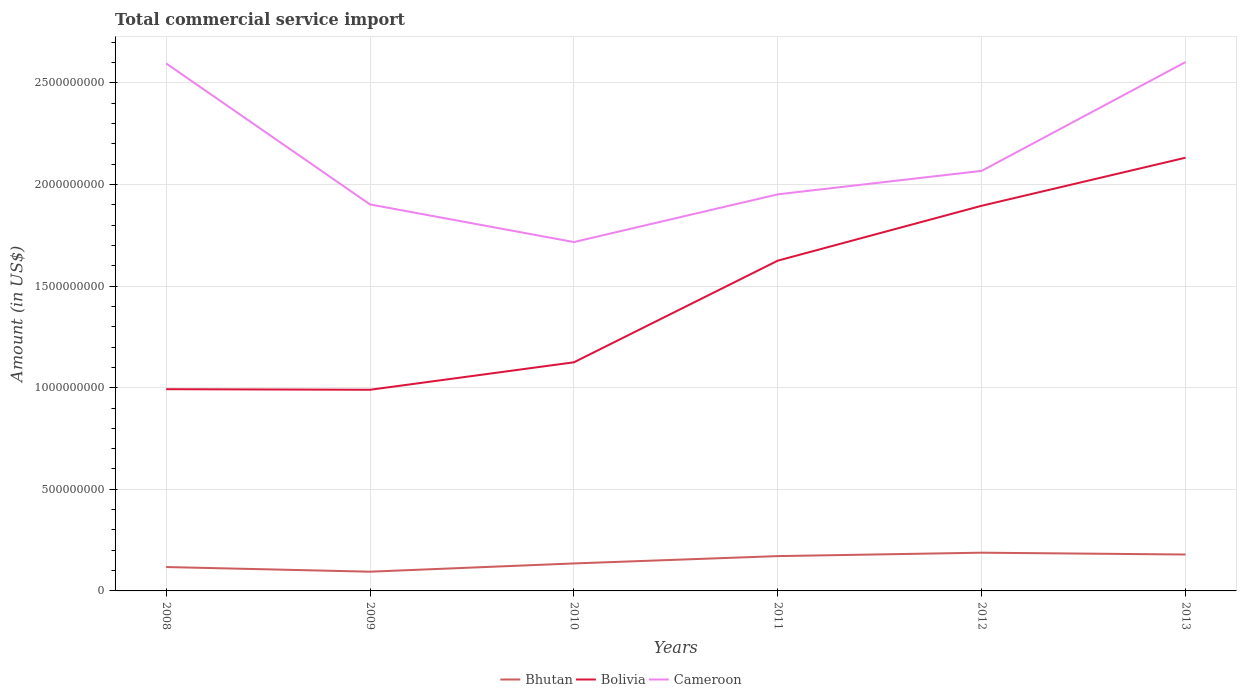How many different coloured lines are there?
Your answer should be very brief. 3. Is the number of lines equal to the number of legend labels?
Ensure brevity in your answer.  Yes. Across all years, what is the maximum total commercial service import in Bolivia?
Make the answer very short. 9.90e+08. What is the total total commercial service import in Bolivia in the graph?
Make the answer very short. 2.86e+06. What is the difference between the highest and the second highest total commercial service import in Cameroon?
Make the answer very short. 8.86e+08. Is the total commercial service import in Bhutan strictly greater than the total commercial service import in Bolivia over the years?
Give a very brief answer. Yes. How many lines are there?
Provide a succinct answer. 3. Are the values on the major ticks of Y-axis written in scientific E-notation?
Provide a short and direct response. No. Does the graph contain grids?
Ensure brevity in your answer.  Yes. How are the legend labels stacked?
Your answer should be compact. Horizontal. What is the title of the graph?
Make the answer very short. Total commercial service import. What is the label or title of the X-axis?
Give a very brief answer. Years. What is the Amount (in US$) of Bhutan in 2008?
Provide a succinct answer. 1.18e+08. What is the Amount (in US$) of Bolivia in 2008?
Keep it short and to the point. 9.93e+08. What is the Amount (in US$) in Cameroon in 2008?
Your response must be concise. 2.60e+09. What is the Amount (in US$) of Bhutan in 2009?
Your response must be concise. 9.46e+07. What is the Amount (in US$) of Bolivia in 2009?
Keep it short and to the point. 9.90e+08. What is the Amount (in US$) of Cameroon in 2009?
Provide a short and direct response. 1.90e+09. What is the Amount (in US$) of Bhutan in 2010?
Make the answer very short. 1.35e+08. What is the Amount (in US$) in Bolivia in 2010?
Give a very brief answer. 1.13e+09. What is the Amount (in US$) of Cameroon in 2010?
Give a very brief answer. 1.72e+09. What is the Amount (in US$) of Bhutan in 2011?
Ensure brevity in your answer.  1.71e+08. What is the Amount (in US$) of Bolivia in 2011?
Offer a terse response. 1.63e+09. What is the Amount (in US$) in Cameroon in 2011?
Your response must be concise. 1.95e+09. What is the Amount (in US$) in Bhutan in 2012?
Your response must be concise. 1.88e+08. What is the Amount (in US$) of Bolivia in 2012?
Keep it short and to the point. 1.90e+09. What is the Amount (in US$) in Cameroon in 2012?
Offer a very short reply. 2.07e+09. What is the Amount (in US$) in Bhutan in 2013?
Offer a terse response. 1.79e+08. What is the Amount (in US$) in Bolivia in 2013?
Provide a short and direct response. 2.13e+09. What is the Amount (in US$) in Cameroon in 2013?
Your answer should be compact. 2.60e+09. Across all years, what is the maximum Amount (in US$) in Bhutan?
Provide a succinct answer. 1.88e+08. Across all years, what is the maximum Amount (in US$) in Bolivia?
Ensure brevity in your answer.  2.13e+09. Across all years, what is the maximum Amount (in US$) in Cameroon?
Offer a terse response. 2.60e+09. Across all years, what is the minimum Amount (in US$) of Bhutan?
Offer a very short reply. 9.46e+07. Across all years, what is the minimum Amount (in US$) of Bolivia?
Offer a terse response. 9.90e+08. Across all years, what is the minimum Amount (in US$) of Cameroon?
Offer a very short reply. 1.72e+09. What is the total Amount (in US$) of Bhutan in the graph?
Offer a very short reply. 8.86e+08. What is the total Amount (in US$) of Bolivia in the graph?
Your response must be concise. 8.76e+09. What is the total Amount (in US$) in Cameroon in the graph?
Your response must be concise. 1.28e+1. What is the difference between the Amount (in US$) in Bhutan in 2008 and that in 2009?
Provide a short and direct response. 2.29e+07. What is the difference between the Amount (in US$) in Bolivia in 2008 and that in 2009?
Provide a short and direct response. 2.86e+06. What is the difference between the Amount (in US$) in Cameroon in 2008 and that in 2009?
Provide a short and direct response. 6.94e+08. What is the difference between the Amount (in US$) in Bhutan in 2008 and that in 2010?
Provide a short and direct response. -1.77e+07. What is the difference between the Amount (in US$) of Bolivia in 2008 and that in 2010?
Give a very brief answer. -1.32e+08. What is the difference between the Amount (in US$) of Cameroon in 2008 and that in 2010?
Ensure brevity in your answer.  8.79e+08. What is the difference between the Amount (in US$) in Bhutan in 2008 and that in 2011?
Keep it short and to the point. -5.38e+07. What is the difference between the Amount (in US$) of Bolivia in 2008 and that in 2011?
Your answer should be compact. -6.33e+08. What is the difference between the Amount (in US$) in Cameroon in 2008 and that in 2011?
Offer a terse response. 6.44e+08. What is the difference between the Amount (in US$) of Bhutan in 2008 and that in 2012?
Offer a terse response. -7.06e+07. What is the difference between the Amount (in US$) in Bolivia in 2008 and that in 2012?
Give a very brief answer. -9.03e+08. What is the difference between the Amount (in US$) in Cameroon in 2008 and that in 2012?
Offer a terse response. 5.29e+08. What is the difference between the Amount (in US$) of Bhutan in 2008 and that in 2013?
Your answer should be compact. -6.16e+07. What is the difference between the Amount (in US$) of Bolivia in 2008 and that in 2013?
Make the answer very short. -1.14e+09. What is the difference between the Amount (in US$) in Cameroon in 2008 and that in 2013?
Make the answer very short. -6.72e+06. What is the difference between the Amount (in US$) in Bhutan in 2009 and that in 2010?
Make the answer very short. -4.06e+07. What is the difference between the Amount (in US$) of Bolivia in 2009 and that in 2010?
Your response must be concise. -1.35e+08. What is the difference between the Amount (in US$) in Cameroon in 2009 and that in 2010?
Your answer should be very brief. 1.85e+08. What is the difference between the Amount (in US$) in Bhutan in 2009 and that in 2011?
Your response must be concise. -7.67e+07. What is the difference between the Amount (in US$) of Bolivia in 2009 and that in 2011?
Offer a very short reply. -6.35e+08. What is the difference between the Amount (in US$) of Cameroon in 2009 and that in 2011?
Keep it short and to the point. -4.97e+07. What is the difference between the Amount (in US$) of Bhutan in 2009 and that in 2012?
Offer a very short reply. -9.35e+07. What is the difference between the Amount (in US$) of Bolivia in 2009 and that in 2012?
Ensure brevity in your answer.  -9.05e+08. What is the difference between the Amount (in US$) in Cameroon in 2009 and that in 2012?
Offer a very short reply. -1.65e+08. What is the difference between the Amount (in US$) of Bhutan in 2009 and that in 2013?
Your answer should be compact. -8.45e+07. What is the difference between the Amount (in US$) in Bolivia in 2009 and that in 2013?
Offer a very short reply. -1.14e+09. What is the difference between the Amount (in US$) of Cameroon in 2009 and that in 2013?
Provide a succinct answer. -7.01e+08. What is the difference between the Amount (in US$) of Bhutan in 2010 and that in 2011?
Provide a succinct answer. -3.61e+07. What is the difference between the Amount (in US$) in Bolivia in 2010 and that in 2011?
Your answer should be compact. -5.00e+08. What is the difference between the Amount (in US$) of Cameroon in 2010 and that in 2011?
Give a very brief answer. -2.35e+08. What is the difference between the Amount (in US$) in Bhutan in 2010 and that in 2012?
Provide a short and direct response. -5.29e+07. What is the difference between the Amount (in US$) in Bolivia in 2010 and that in 2012?
Your answer should be compact. -7.70e+08. What is the difference between the Amount (in US$) in Cameroon in 2010 and that in 2012?
Offer a terse response. -3.50e+08. What is the difference between the Amount (in US$) in Bhutan in 2010 and that in 2013?
Ensure brevity in your answer.  -4.39e+07. What is the difference between the Amount (in US$) of Bolivia in 2010 and that in 2013?
Provide a short and direct response. -1.01e+09. What is the difference between the Amount (in US$) in Cameroon in 2010 and that in 2013?
Make the answer very short. -8.86e+08. What is the difference between the Amount (in US$) in Bhutan in 2011 and that in 2012?
Provide a succinct answer. -1.68e+07. What is the difference between the Amount (in US$) of Bolivia in 2011 and that in 2012?
Your response must be concise. -2.70e+08. What is the difference between the Amount (in US$) in Cameroon in 2011 and that in 2012?
Ensure brevity in your answer.  -1.15e+08. What is the difference between the Amount (in US$) in Bhutan in 2011 and that in 2013?
Your response must be concise. -7.82e+06. What is the difference between the Amount (in US$) in Bolivia in 2011 and that in 2013?
Offer a terse response. -5.07e+08. What is the difference between the Amount (in US$) of Cameroon in 2011 and that in 2013?
Give a very brief answer. -6.51e+08. What is the difference between the Amount (in US$) in Bhutan in 2012 and that in 2013?
Ensure brevity in your answer.  8.97e+06. What is the difference between the Amount (in US$) of Bolivia in 2012 and that in 2013?
Make the answer very short. -2.37e+08. What is the difference between the Amount (in US$) in Cameroon in 2012 and that in 2013?
Provide a short and direct response. -5.35e+08. What is the difference between the Amount (in US$) of Bhutan in 2008 and the Amount (in US$) of Bolivia in 2009?
Provide a short and direct response. -8.72e+08. What is the difference between the Amount (in US$) of Bhutan in 2008 and the Amount (in US$) of Cameroon in 2009?
Your response must be concise. -1.78e+09. What is the difference between the Amount (in US$) of Bolivia in 2008 and the Amount (in US$) of Cameroon in 2009?
Make the answer very short. -9.09e+08. What is the difference between the Amount (in US$) of Bhutan in 2008 and the Amount (in US$) of Bolivia in 2010?
Offer a terse response. -1.01e+09. What is the difference between the Amount (in US$) of Bhutan in 2008 and the Amount (in US$) of Cameroon in 2010?
Keep it short and to the point. -1.60e+09. What is the difference between the Amount (in US$) of Bolivia in 2008 and the Amount (in US$) of Cameroon in 2010?
Make the answer very short. -7.24e+08. What is the difference between the Amount (in US$) in Bhutan in 2008 and the Amount (in US$) in Bolivia in 2011?
Make the answer very short. -1.51e+09. What is the difference between the Amount (in US$) in Bhutan in 2008 and the Amount (in US$) in Cameroon in 2011?
Provide a short and direct response. -1.83e+09. What is the difference between the Amount (in US$) in Bolivia in 2008 and the Amount (in US$) in Cameroon in 2011?
Your response must be concise. -9.59e+08. What is the difference between the Amount (in US$) of Bhutan in 2008 and the Amount (in US$) of Bolivia in 2012?
Ensure brevity in your answer.  -1.78e+09. What is the difference between the Amount (in US$) in Bhutan in 2008 and the Amount (in US$) in Cameroon in 2012?
Your answer should be very brief. -1.95e+09. What is the difference between the Amount (in US$) in Bolivia in 2008 and the Amount (in US$) in Cameroon in 2012?
Your response must be concise. -1.07e+09. What is the difference between the Amount (in US$) in Bhutan in 2008 and the Amount (in US$) in Bolivia in 2013?
Your answer should be compact. -2.01e+09. What is the difference between the Amount (in US$) of Bhutan in 2008 and the Amount (in US$) of Cameroon in 2013?
Keep it short and to the point. -2.48e+09. What is the difference between the Amount (in US$) in Bolivia in 2008 and the Amount (in US$) in Cameroon in 2013?
Make the answer very short. -1.61e+09. What is the difference between the Amount (in US$) in Bhutan in 2009 and the Amount (in US$) in Bolivia in 2010?
Give a very brief answer. -1.03e+09. What is the difference between the Amount (in US$) in Bhutan in 2009 and the Amount (in US$) in Cameroon in 2010?
Offer a very short reply. -1.62e+09. What is the difference between the Amount (in US$) of Bolivia in 2009 and the Amount (in US$) of Cameroon in 2010?
Your answer should be very brief. -7.27e+08. What is the difference between the Amount (in US$) in Bhutan in 2009 and the Amount (in US$) in Bolivia in 2011?
Provide a short and direct response. -1.53e+09. What is the difference between the Amount (in US$) of Bhutan in 2009 and the Amount (in US$) of Cameroon in 2011?
Keep it short and to the point. -1.86e+09. What is the difference between the Amount (in US$) of Bolivia in 2009 and the Amount (in US$) of Cameroon in 2011?
Ensure brevity in your answer.  -9.62e+08. What is the difference between the Amount (in US$) of Bhutan in 2009 and the Amount (in US$) of Bolivia in 2012?
Make the answer very short. -1.80e+09. What is the difference between the Amount (in US$) of Bhutan in 2009 and the Amount (in US$) of Cameroon in 2012?
Make the answer very short. -1.97e+09. What is the difference between the Amount (in US$) of Bolivia in 2009 and the Amount (in US$) of Cameroon in 2012?
Your response must be concise. -1.08e+09. What is the difference between the Amount (in US$) in Bhutan in 2009 and the Amount (in US$) in Bolivia in 2013?
Offer a very short reply. -2.04e+09. What is the difference between the Amount (in US$) of Bhutan in 2009 and the Amount (in US$) of Cameroon in 2013?
Your answer should be compact. -2.51e+09. What is the difference between the Amount (in US$) in Bolivia in 2009 and the Amount (in US$) in Cameroon in 2013?
Your answer should be very brief. -1.61e+09. What is the difference between the Amount (in US$) of Bhutan in 2010 and the Amount (in US$) of Bolivia in 2011?
Your answer should be compact. -1.49e+09. What is the difference between the Amount (in US$) in Bhutan in 2010 and the Amount (in US$) in Cameroon in 2011?
Offer a very short reply. -1.82e+09. What is the difference between the Amount (in US$) in Bolivia in 2010 and the Amount (in US$) in Cameroon in 2011?
Keep it short and to the point. -8.27e+08. What is the difference between the Amount (in US$) in Bhutan in 2010 and the Amount (in US$) in Bolivia in 2012?
Offer a terse response. -1.76e+09. What is the difference between the Amount (in US$) in Bhutan in 2010 and the Amount (in US$) in Cameroon in 2012?
Your response must be concise. -1.93e+09. What is the difference between the Amount (in US$) in Bolivia in 2010 and the Amount (in US$) in Cameroon in 2012?
Give a very brief answer. -9.42e+08. What is the difference between the Amount (in US$) in Bhutan in 2010 and the Amount (in US$) in Bolivia in 2013?
Provide a succinct answer. -2.00e+09. What is the difference between the Amount (in US$) of Bhutan in 2010 and the Amount (in US$) of Cameroon in 2013?
Ensure brevity in your answer.  -2.47e+09. What is the difference between the Amount (in US$) of Bolivia in 2010 and the Amount (in US$) of Cameroon in 2013?
Your response must be concise. -1.48e+09. What is the difference between the Amount (in US$) of Bhutan in 2011 and the Amount (in US$) of Bolivia in 2012?
Offer a terse response. -1.72e+09. What is the difference between the Amount (in US$) of Bhutan in 2011 and the Amount (in US$) of Cameroon in 2012?
Offer a very short reply. -1.90e+09. What is the difference between the Amount (in US$) in Bolivia in 2011 and the Amount (in US$) in Cameroon in 2012?
Provide a succinct answer. -4.42e+08. What is the difference between the Amount (in US$) in Bhutan in 2011 and the Amount (in US$) in Bolivia in 2013?
Give a very brief answer. -1.96e+09. What is the difference between the Amount (in US$) in Bhutan in 2011 and the Amount (in US$) in Cameroon in 2013?
Provide a short and direct response. -2.43e+09. What is the difference between the Amount (in US$) in Bolivia in 2011 and the Amount (in US$) in Cameroon in 2013?
Your answer should be very brief. -9.77e+08. What is the difference between the Amount (in US$) of Bhutan in 2012 and the Amount (in US$) of Bolivia in 2013?
Provide a succinct answer. -1.94e+09. What is the difference between the Amount (in US$) of Bhutan in 2012 and the Amount (in US$) of Cameroon in 2013?
Ensure brevity in your answer.  -2.41e+09. What is the difference between the Amount (in US$) in Bolivia in 2012 and the Amount (in US$) in Cameroon in 2013?
Provide a succinct answer. -7.07e+08. What is the average Amount (in US$) of Bhutan per year?
Keep it short and to the point. 1.48e+08. What is the average Amount (in US$) in Bolivia per year?
Provide a succinct answer. 1.46e+09. What is the average Amount (in US$) in Cameroon per year?
Your answer should be compact. 2.14e+09. In the year 2008, what is the difference between the Amount (in US$) in Bhutan and Amount (in US$) in Bolivia?
Your answer should be compact. -8.75e+08. In the year 2008, what is the difference between the Amount (in US$) in Bhutan and Amount (in US$) in Cameroon?
Provide a succinct answer. -2.48e+09. In the year 2008, what is the difference between the Amount (in US$) in Bolivia and Amount (in US$) in Cameroon?
Provide a succinct answer. -1.60e+09. In the year 2009, what is the difference between the Amount (in US$) in Bhutan and Amount (in US$) in Bolivia?
Offer a very short reply. -8.95e+08. In the year 2009, what is the difference between the Amount (in US$) in Bhutan and Amount (in US$) in Cameroon?
Make the answer very short. -1.81e+09. In the year 2009, what is the difference between the Amount (in US$) of Bolivia and Amount (in US$) of Cameroon?
Provide a short and direct response. -9.12e+08. In the year 2010, what is the difference between the Amount (in US$) of Bhutan and Amount (in US$) of Bolivia?
Provide a succinct answer. -9.90e+08. In the year 2010, what is the difference between the Amount (in US$) in Bhutan and Amount (in US$) in Cameroon?
Give a very brief answer. -1.58e+09. In the year 2010, what is the difference between the Amount (in US$) in Bolivia and Amount (in US$) in Cameroon?
Your answer should be very brief. -5.92e+08. In the year 2011, what is the difference between the Amount (in US$) in Bhutan and Amount (in US$) in Bolivia?
Your answer should be compact. -1.45e+09. In the year 2011, what is the difference between the Amount (in US$) in Bhutan and Amount (in US$) in Cameroon?
Provide a succinct answer. -1.78e+09. In the year 2011, what is the difference between the Amount (in US$) of Bolivia and Amount (in US$) of Cameroon?
Your response must be concise. -3.26e+08. In the year 2012, what is the difference between the Amount (in US$) in Bhutan and Amount (in US$) in Bolivia?
Offer a terse response. -1.71e+09. In the year 2012, what is the difference between the Amount (in US$) of Bhutan and Amount (in US$) of Cameroon?
Give a very brief answer. -1.88e+09. In the year 2012, what is the difference between the Amount (in US$) in Bolivia and Amount (in US$) in Cameroon?
Offer a very short reply. -1.72e+08. In the year 2013, what is the difference between the Amount (in US$) of Bhutan and Amount (in US$) of Bolivia?
Provide a succinct answer. -1.95e+09. In the year 2013, what is the difference between the Amount (in US$) in Bhutan and Amount (in US$) in Cameroon?
Offer a very short reply. -2.42e+09. In the year 2013, what is the difference between the Amount (in US$) in Bolivia and Amount (in US$) in Cameroon?
Give a very brief answer. -4.71e+08. What is the ratio of the Amount (in US$) in Bhutan in 2008 to that in 2009?
Make the answer very short. 1.24. What is the ratio of the Amount (in US$) in Bolivia in 2008 to that in 2009?
Offer a very short reply. 1. What is the ratio of the Amount (in US$) in Cameroon in 2008 to that in 2009?
Ensure brevity in your answer.  1.36. What is the ratio of the Amount (in US$) of Bhutan in 2008 to that in 2010?
Make the answer very short. 0.87. What is the ratio of the Amount (in US$) of Bolivia in 2008 to that in 2010?
Your answer should be very brief. 0.88. What is the ratio of the Amount (in US$) of Cameroon in 2008 to that in 2010?
Give a very brief answer. 1.51. What is the ratio of the Amount (in US$) of Bhutan in 2008 to that in 2011?
Provide a succinct answer. 0.69. What is the ratio of the Amount (in US$) in Bolivia in 2008 to that in 2011?
Your response must be concise. 0.61. What is the ratio of the Amount (in US$) in Cameroon in 2008 to that in 2011?
Your answer should be compact. 1.33. What is the ratio of the Amount (in US$) in Bhutan in 2008 to that in 2012?
Keep it short and to the point. 0.62. What is the ratio of the Amount (in US$) of Bolivia in 2008 to that in 2012?
Give a very brief answer. 0.52. What is the ratio of the Amount (in US$) in Cameroon in 2008 to that in 2012?
Give a very brief answer. 1.26. What is the ratio of the Amount (in US$) in Bhutan in 2008 to that in 2013?
Provide a short and direct response. 0.66. What is the ratio of the Amount (in US$) of Bolivia in 2008 to that in 2013?
Keep it short and to the point. 0.47. What is the ratio of the Amount (in US$) in Cameroon in 2008 to that in 2013?
Give a very brief answer. 1. What is the ratio of the Amount (in US$) in Bhutan in 2009 to that in 2010?
Provide a succinct answer. 0.7. What is the ratio of the Amount (in US$) in Bolivia in 2009 to that in 2010?
Your response must be concise. 0.88. What is the ratio of the Amount (in US$) of Cameroon in 2009 to that in 2010?
Your answer should be very brief. 1.11. What is the ratio of the Amount (in US$) in Bhutan in 2009 to that in 2011?
Ensure brevity in your answer.  0.55. What is the ratio of the Amount (in US$) in Bolivia in 2009 to that in 2011?
Your answer should be very brief. 0.61. What is the ratio of the Amount (in US$) in Cameroon in 2009 to that in 2011?
Your answer should be very brief. 0.97. What is the ratio of the Amount (in US$) in Bhutan in 2009 to that in 2012?
Provide a succinct answer. 0.5. What is the ratio of the Amount (in US$) of Bolivia in 2009 to that in 2012?
Provide a short and direct response. 0.52. What is the ratio of the Amount (in US$) of Cameroon in 2009 to that in 2012?
Make the answer very short. 0.92. What is the ratio of the Amount (in US$) in Bhutan in 2009 to that in 2013?
Your response must be concise. 0.53. What is the ratio of the Amount (in US$) in Bolivia in 2009 to that in 2013?
Offer a terse response. 0.46. What is the ratio of the Amount (in US$) in Cameroon in 2009 to that in 2013?
Ensure brevity in your answer.  0.73. What is the ratio of the Amount (in US$) in Bhutan in 2010 to that in 2011?
Offer a terse response. 0.79. What is the ratio of the Amount (in US$) of Bolivia in 2010 to that in 2011?
Make the answer very short. 0.69. What is the ratio of the Amount (in US$) in Cameroon in 2010 to that in 2011?
Give a very brief answer. 0.88. What is the ratio of the Amount (in US$) in Bhutan in 2010 to that in 2012?
Provide a short and direct response. 0.72. What is the ratio of the Amount (in US$) in Bolivia in 2010 to that in 2012?
Provide a short and direct response. 0.59. What is the ratio of the Amount (in US$) in Cameroon in 2010 to that in 2012?
Provide a short and direct response. 0.83. What is the ratio of the Amount (in US$) of Bhutan in 2010 to that in 2013?
Give a very brief answer. 0.76. What is the ratio of the Amount (in US$) in Bolivia in 2010 to that in 2013?
Your response must be concise. 0.53. What is the ratio of the Amount (in US$) in Cameroon in 2010 to that in 2013?
Ensure brevity in your answer.  0.66. What is the ratio of the Amount (in US$) in Bhutan in 2011 to that in 2012?
Keep it short and to the point. 0.91. What is the ratio of the Amount (in US$) of Bolivia in 2011 to that in 2012?
Make the answer very short. 0.86. What is the ratio of the Amount (in US$) of Cameroon in 2011 to that in 2012?
Your answer should be compact. 0.94. What is the ratio of the Amount (in US$) in Bhutan in 2011 to that in 2013?
Offer a very short reply. 0.96. What is the ratio of the Amount (in US$) of Bolivia in 2011 to that in 2013?
Keep it short and to the point. 0.76. What is the ratio of the Amount (in US$) of Cameroon in 2011 to that in 2013?
Provide a short and direct response. 0.75. What is the ratio of the Amount (in US$) of Bhutan in 2012 to that in 2013?
Give a very brief answer. 1.05. What is the ratio of the Amount (in US$) of Bolivia in 2012 to that in 2013?
Your answer should be compact. 0.89. What is the ratio of the Amount (in US$) in Cameroon in 2012 to that in 2013?
Give a very brief answer. 0.79. What is the difference between the highest and the second highest Amount (in US$) of Bhutan?
Make the answer very short. 8.97e+06. What is the difference between the highest and the second highest Amount (in US$) of Bolivia?
Your answer should be very brief. 2.37e+08. What is the difference between the highest and the second highest Amount (in US$) of Cameroon?
Your answer should be compact. 6.72e+06. What is the difference between the highest and the lowest Amount (in US$) in Bhutan?
Provide a short and direct response. 9.35e+07. What is the difference between the highest and the lowest Amount (in US$) of Bolivia?
Keep it short and to the point. 1.14e+09. What is the difference between the highest and the lowest Amount (in US$) in Cameroon?
Provide a short and direct response. 8.86e+08. 